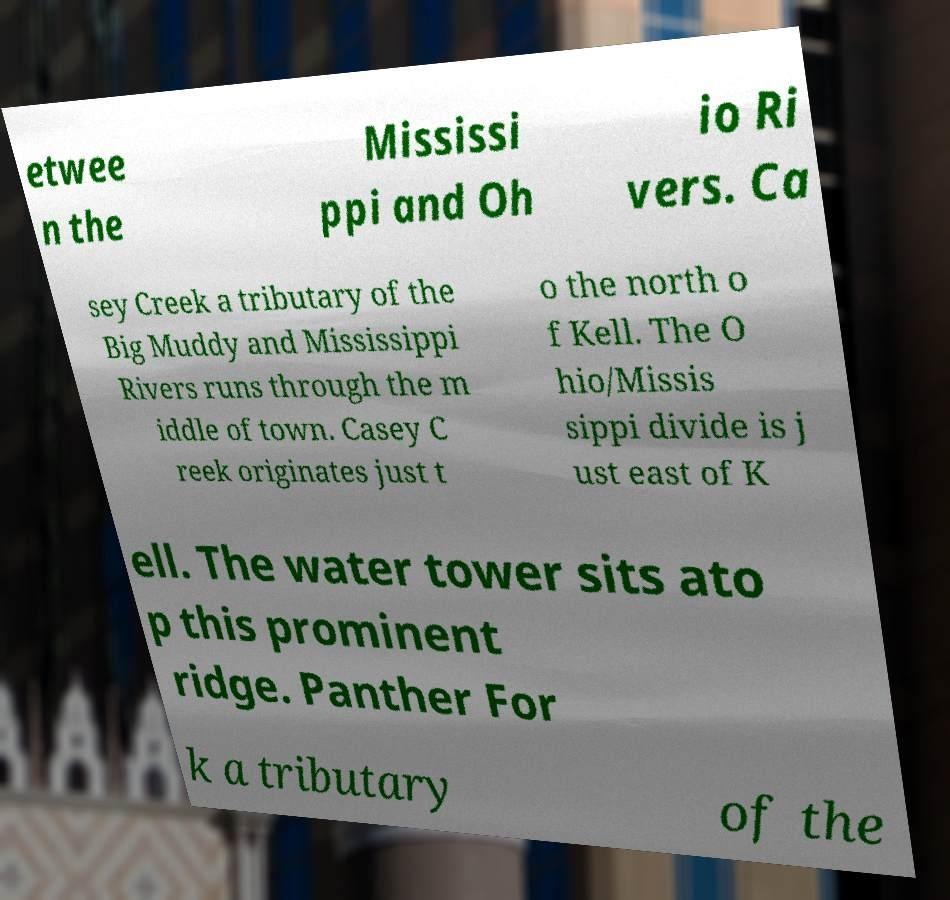Can you read and provide the text displayed in the image?This photo seems to have some interesting text. Can you extract and type it out for me? etwee n the Mississi ppi and Oh io Ri vers. Ca sey Creek a tributary of the Big Muddy and Mississippi Rivers runs through the m iddle of town. Casey C reek originates just t o the north o f Kell. The O hio/Missis sippi divide is j ust east of K ell. The water tower sits ato p this prominent ridge. Panther For k a tributary of the 